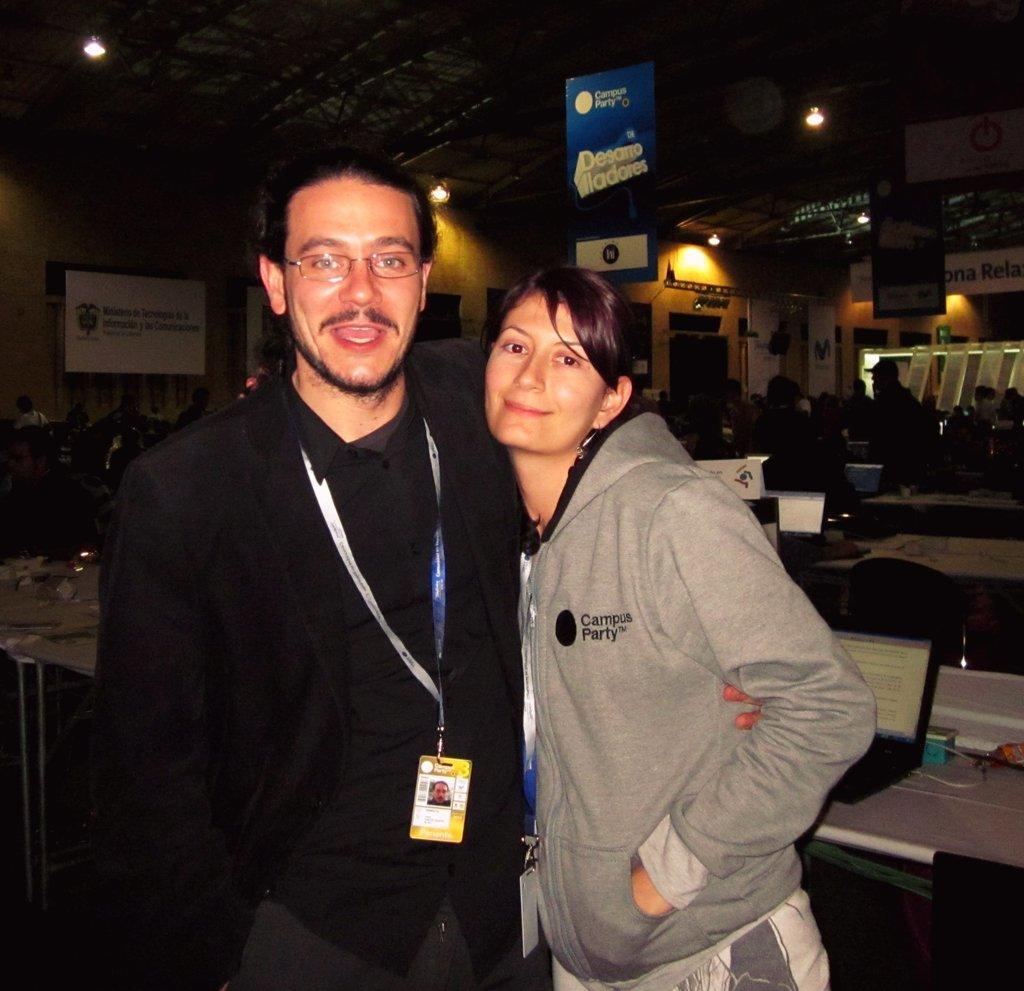Describe this image in one or two sentences. In the middle a man is standing. He wear a black color shirt and ID card is smiling. He wear a spectacles beside a girl is standing she is wearing a grey color coat behind them there are lights on the top and laptop in the right. 